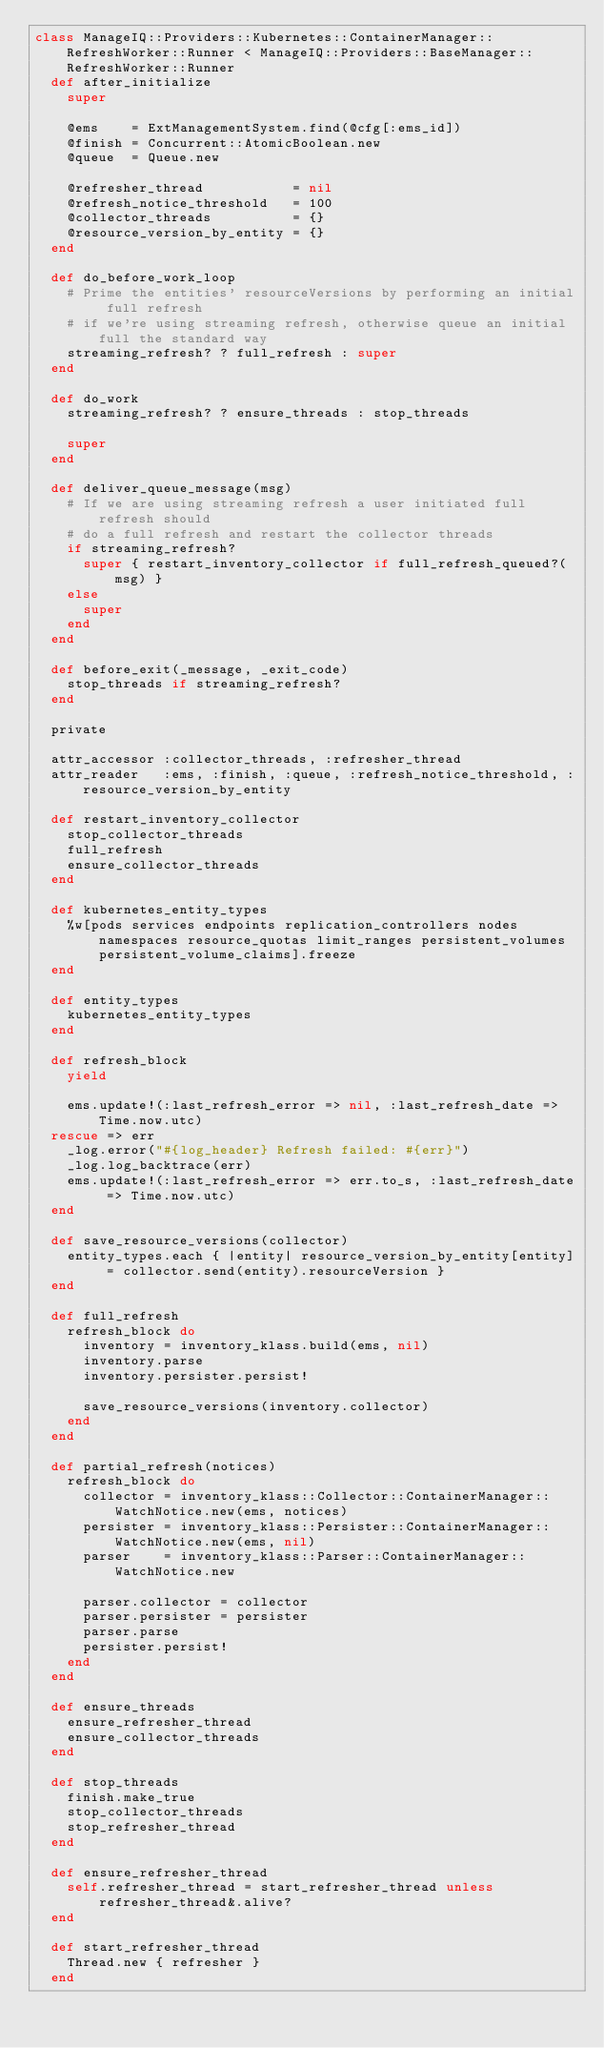Convert code to text. <code><loc_0><loc_0><loc_500><loc_500><_Ruby_>class ManageIQ::Providers::Kubernetes::ContainerManager::RefreshWorker::Runner < ManageIQ::Providers::BaseManager::RefreshWorker::Runner
  def after_initialize
    super

    @ems    = ExtManagementSystem.find(@cfg[:ems_id])
    @finish = Concurrent::AtomicBoolean.new
    @queue  = Queue.new

    @refresher_thread           = nil
    @refresh_notice_threshold   = 100
    @collector_threads          = {}
    @resource_version_by_entity = {}
  end

  def do_before_work_loop
    # Prime the entities' resourceVersions by performing an initial full refresh
    # if we're using streaming refresh, otherwise queue an initial full the standard way
    streaming_refresh? ? full_refresh : super
  end

  def do_work
    streaming_refresh? ? ensure_threads : stop_threads

    super
  end

  def deliver_queue_message(msg)
    # If we are using streaming refresh a user initiated full refresh should
    # do a full refresh and restart the collector threads
    if streaming_refresh?
      super { restart_inventory_collector if full_refresh_queued?(msg) }
    else
      super
    end
  end

  def before_exit(_message, _exit_code)
    stop_threads if streaming_refresh?
  end

  private

  attr_accessor :collector_threads, :refresher_thread
  attr_reader   :ems, :finish, :queue, :refresh_notice_threshold, :resource_version_by_entity

  def restart_inventory_collector
    stop_collector_threads
    full_refresh
    ensure_collector_threads
  end

  def kubernetes_entity_types
    %w[pods services endpoints replication_controllers nodes namespaces resource_quotas limit_ranges persistent_volumes persistent_volume_claims].freeze
  end

  def entity_types
    kubernetes_entity_types
  end

  def refresh_block
    yield

    ems.update!(:last_refresh_error => nil, :last_refresh_date => Time.now.utc)
  rescue => err
    _log.error("#{log_header} Refresh failed: #{err}")
    _log.log_backtrace(err)
    ems.update!(:last_refresh_error => err.to_s, :last_refresh_date => Time.now.utc)
  end

  def save_resource_versions(collector)
    entity_types.each { |entity| resource_version_by_entity[entity] = collector.send(entity).resourceVersion }
  end

  def full_refresh
    refresh_block do
      inventory = inventory_klass.build(ems, nil)
      inventory.parse
      inventory.persister.persist!

      save_resource_versions(inventory.collector)
    end
  end

  def partial_refresh(notices)
    refresh_block do
      collector = inventory_klass::Collector::ContainerManager::WatchNotice.new(ems, notices)
      persister = inventory_klass::Persister::ContainerManager::WatchNotice.new(ems, nil)
      parser    = inventory_klass::Parser::ContainerManager::WatchNotice.new

      parser.collector = collector
      parser.persister = persister
      parser.parse
      persister.persist!
    end
  end

  def ensure_threads
    ensure_refresher_thread
    ensure_collector_threads
  end

  def stop_threads
    finish.make_true
    stop_collector_threads
    stop_refresher_thread
  end

  def ensure_refresher_thread
    self.refresher_thread = start_refresher_thread unless refresher_thread&.alive?
  end

  def start_refresher_thread
    Thread.new { refresher }
  end
</code> 